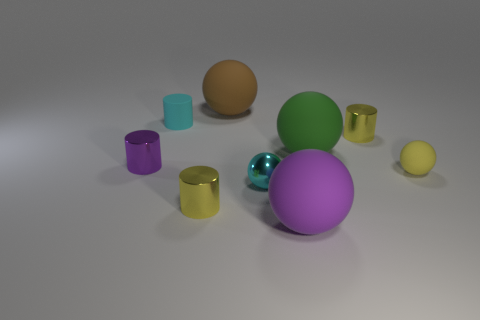There is a purple object in front of the small yellow rubber sphere in front of the small purple metallic cylinder; are there any cyan cylinders behind it?
Provide a short and direct response. Yes. The green matte object that is the same size as the purple matte sphere is what shape?
Give a very brief answer. Sphere. What color is the other shiny thing that is the same shape as the large green thing?
Provide a succinct answer. Cyan. What number of objects are either blue rubber cylinders or tiny metal cylinders?
Your response must be concise. 3. Is the shape of the tiny matte object that is to the left of the shiny sphere the same as the large thing that is in front of the green object?
Provide a succinct answer. No. What shape is the big rubber object that is to the right of the purple ball?
Offer a very short reply. Sphere. Is the number of tiny things that are in front of the big brown rubber sphere the same as the number of big green balls that are in front of the purple matte object?
Make the answer very short. No. How many things are tiny green spheres or yellow cylinders in front of the purple metal thing?
Your answer should be very brief. 1. What is the shape of the shiny object that is both behind the small rubber sphere and left of the large purple thing?
Give a very brief answer. Cylinder. What material is the yellow cylinder that is behind the small rubber object that is on the right side of the cyan matte object?
Offer a terse response. Metal. 